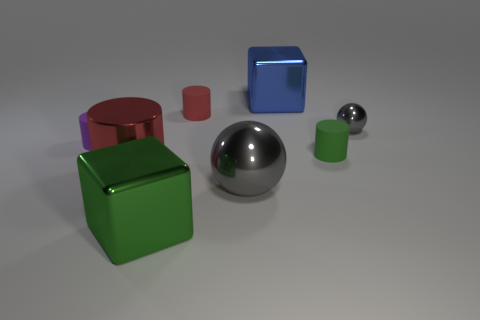Add 1 tiny gray metal objects. How many objects exist? 9 Subtract all large metallic cylinders. How many cylinders are left? 3 Subtract all blocks. How many objects are left? 6 Subtract all green cubes. How many red cylinders are left? 2 Subtract all green metallic things. Subtract all purple rubber cylinders. How many objects are left? 6 Add 4 blue metal cubes. How many blue metal cubes are left? 5 Add 7 green metal blocks. How many green metal blocks exist? 8 Subtract all green cylinders. How many cylinders are left? 3 Subtract 0 gray cubes. How many objects are left? 8 Subtract 2 blocks. How many blocks are left? 0 